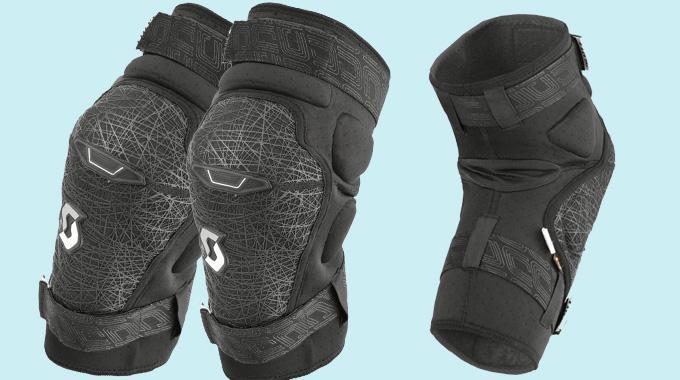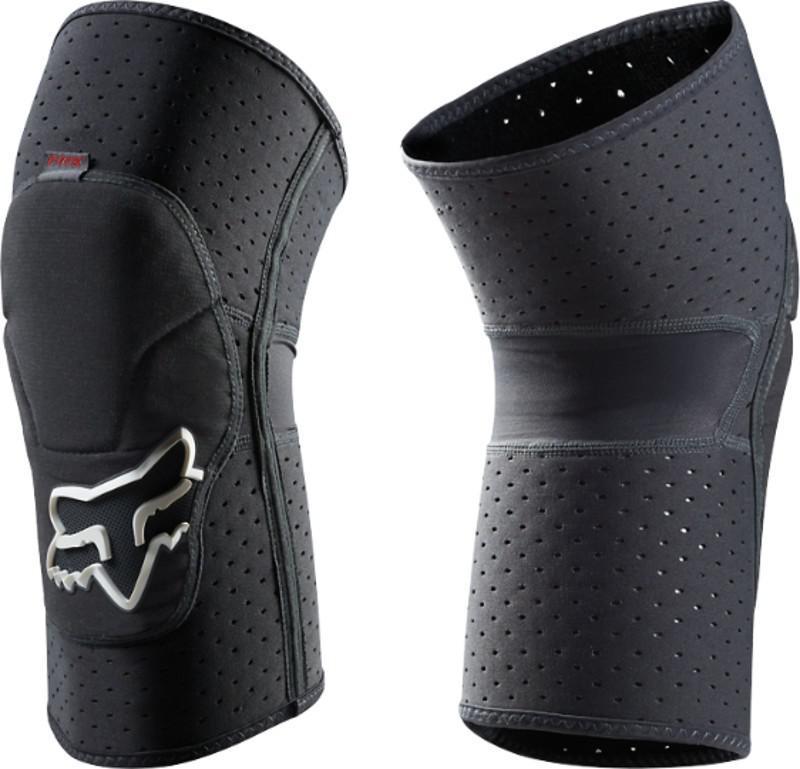The first image is the image on the left, the second image is the image on the right. Analyze the images presented: Is the assertion "The left image features an unworn black knee pad, while the right image shows a pair of human legs wearing a pair of black knee pads." valid? Answer yes or no. No. The first image is the image on the left, the second image is the image on the right. Considering the images on both sides, is "The knee guards are being worn by a person in one of the images." valid? Answer yes or no. No. 